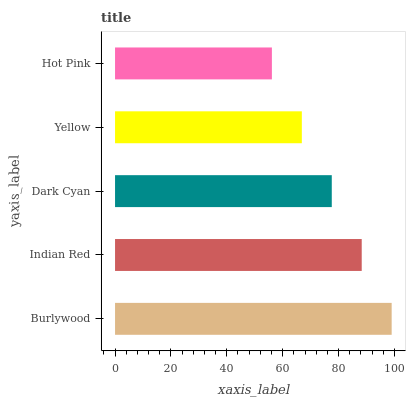Is Hot Pink the minimum?
Answer yes or no. Yes. Is Burlywood the maximum?
Answer yes or no. Yes. Is Indian Red the minimum?
Answer yes or no. No. Is Indian Red the maximum?
Answer yes or no. No. Is Burlywood greater than Indian Red?
Answer yes or no. Yes. Is Indian Red less than Burlywood?
Answer yes or no. Yes. Is Indian Red greater than Burlywood?
Answer yes or no. No. Is Burlywood less than Indian Red?
Answer yes or no. No. Is Dark Cyan the high median?
Answer yes or no. Yes. Is Dark Cyan the low median?
Answer yes or no. Yes. Is Yellow the high median?
Answer yes or no. No. Is Burlywood the low median?
Answer yes or no. No. 